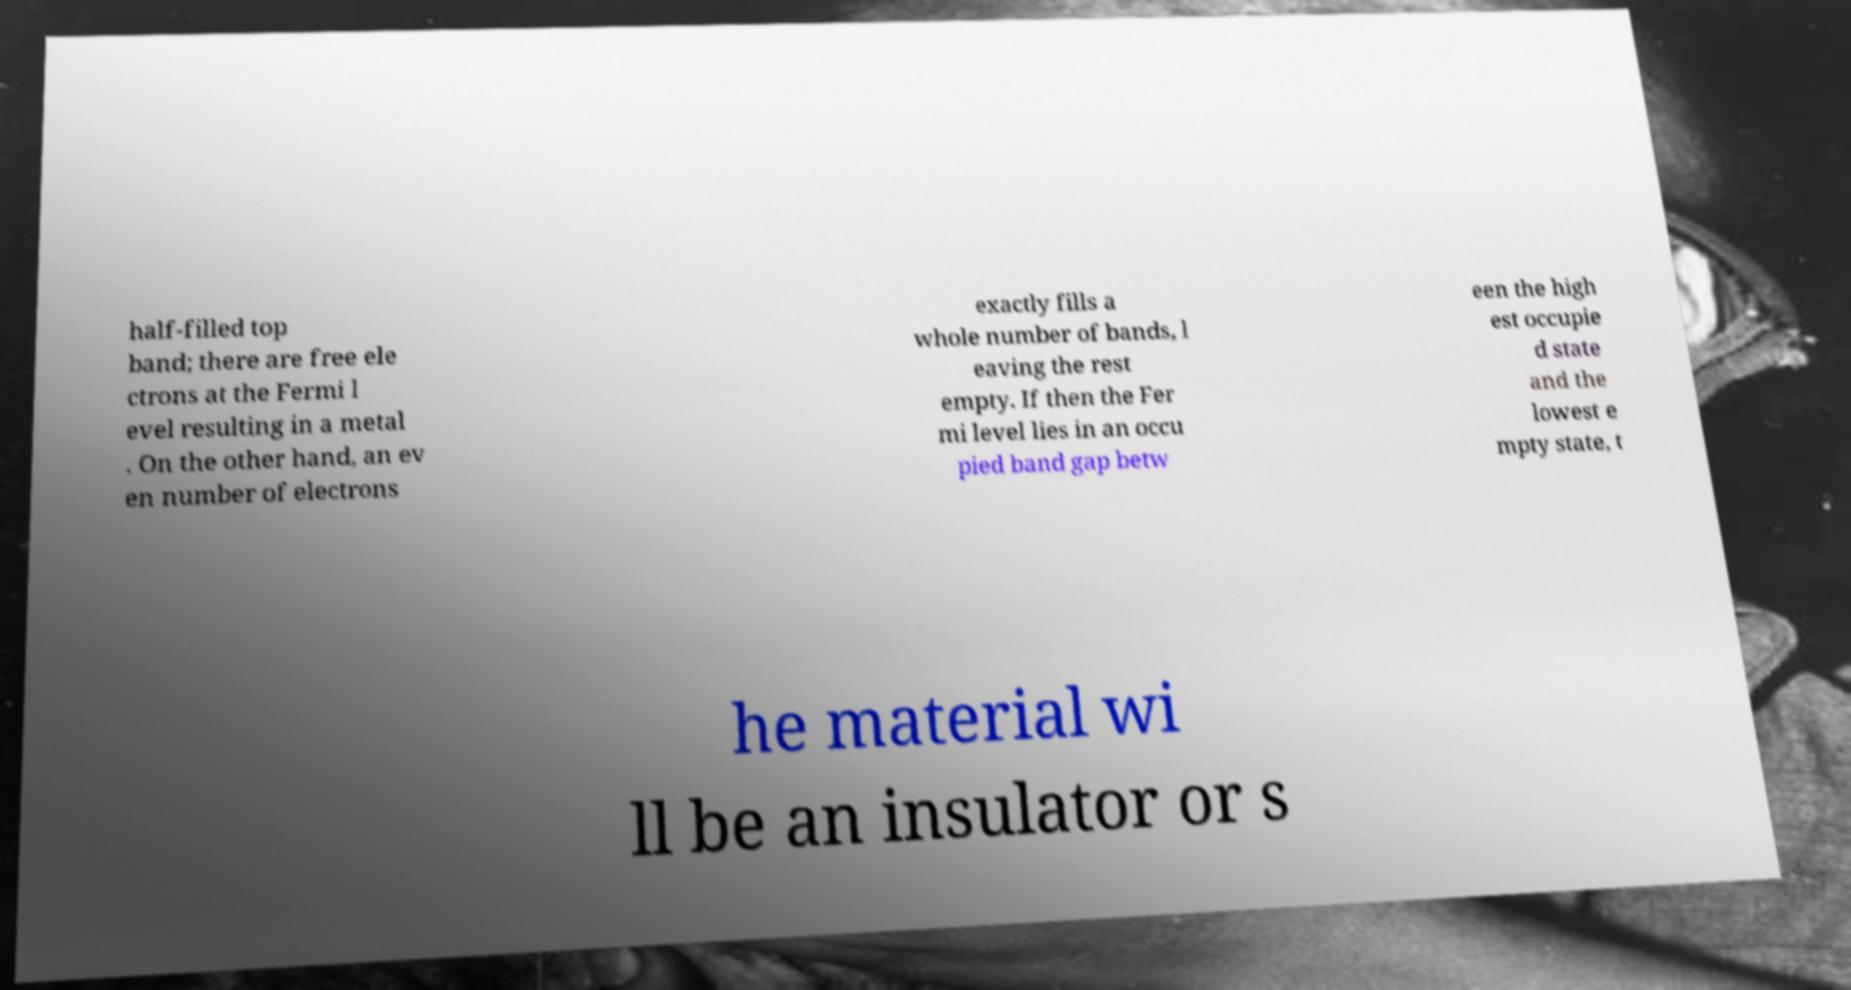Please identify and transcribe the text found in this image. half-filled top band; there are free ele ctrons at the Fermi l evel resulting in a metal . On the other hand, an ev en number of electrons exactly fills a whole number of bands, l eaving the rest empty. If then the Fer mi level lies in an occu pied band gap betw een the high est occupie d state and the lowest e mpty state, t he material wi ll be an insulator or s 